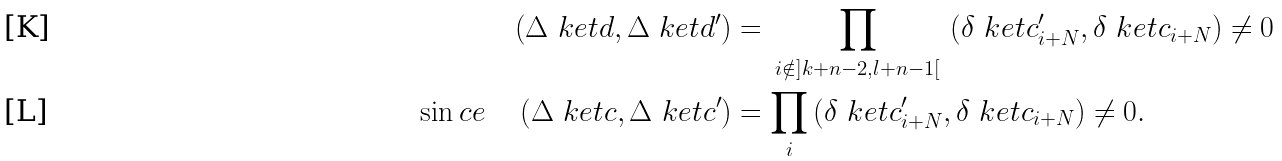<formula> <loc_0><loc_0><loc_500><loc_500>\left ( \Delta \ k e t { d } , \Delta \ k e t { d ^ { \prime } } \right ) & = \, \prod _ { i \notin ] k + n - 2 , l + n - 1 [ } \, \left ( \delta \ k e t { c ^ { \prime } _ { i + N } } , \delta \ k e t { c _ { i + N } } \right ) \neq 0 \\ \sin c e \quad \left ( \Delta \ k e t { c } , \Delta \ k e t { c ^ { \prime } } \right ) & = \prod _ { i } \left ( \delta \ k e t { c ^ { \prime } _ { i + N } } , \delta \ k e t { c _ { i + N } } \right ) \neq 0 .</formula> 